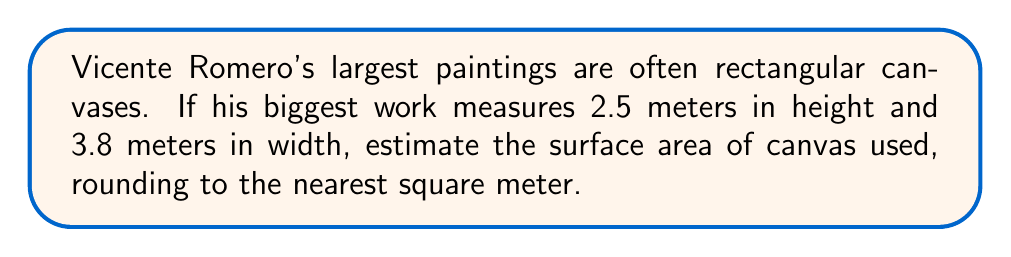Give your solution to this math problem. To estimate the surface area of the canvas, we need to calculate the area of a rectangle. The formula for the area of a rectangle is:

$$A = l \times w$$

Where:
$A$ = Area
$l$ = Length (height in this case)
$w$ = Width

Given:
Height ($l$) = 2.5 meters
Width ($w$) = 3.8 meters

Let's calculate:

$$\begin{align}
A &= 2.5 \text{ m} \times 3.8 \text{ m} \\
&= 9.5 \text{ m}^2
\end{align}$$

Now, we need to round to the nearest square meter:
9.5 rounds up to 10.

Therefore, the estimated surface area of the canvas used in Romero's largest painting, rounded to the nearest square meter, is 10 m².
Answer: 10 m² 